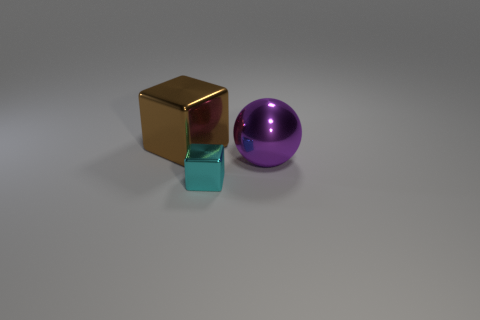Add 2 purple metal objects. How many objects exist? 5 Subtract all spheres. How many objects are left? 2 Add 1 cyan objects. How many cyan objects exist? 2 Subtract 0 brown spheres. How many objects are left? 3 Subtract all large brown shiny things. Subtract all metal blocks. How many objects are left? 0 Add 1 small cyan metallic things. How many small cyan metallic things are left? 2 